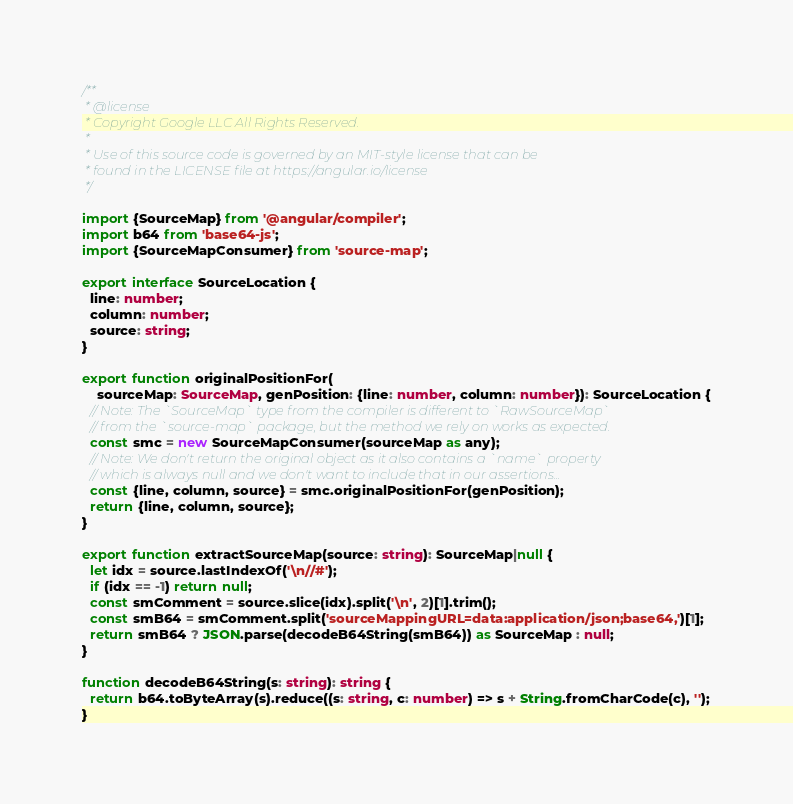Convert code to text. <code><loc_0><loc_0><loc_500><loc_500><_TypeScript_>/**
 * @license
 * Copyright Google LLC All Rights Reserved.
 *
 * Use of this source code is governed by an MIT-style license that can be
 * found in the LICENSE file at https://angular.io/license
 */

import {SourceMap} from '@angular/compiler';
import b64 from 'base64-js';
import {SourceMapConsumer} from 'source-map';

export interface SourceLocation {
  line: number;
  column: number;
  source: string;
}

export function originalPositionFor(
    sourceMap: SourceMap, genPosition: {line: number, column: number}): SourceLocation {
  // Note: The `SourceMap` type from the compiler is different to `RawSourceMap`
  // from the `source-map` package, but the method we rely on works as expected.
  const smc = new SourceMapConsumer(sourceMap as any);
  // Note: We don't return the original object as it also contains a `name` property
  // which is always null and we don't want to include that in our assertions...
  const {line, column, source} = smc.originalPositionFor(genPosition);
  return {line, column, source};
}

export function extractSourceMap(source: string): SourceMap|null {
  let idx = source.lastIndexOf('\n//#');
  if (idx == -1) return null;
  const smComment = source.slice(idx).split('\n', 2)[1].trim();
  const smB64 = smComment.split('sourceMappingURL=data:application/json;base64,')[1];
  return smB64 ? JSON.parse(decodeB64String(smB64)) as SourceMap : null;
}

function decodeB64String(s: string): string {
  return b64.toByteArray(s).reduce((s: string, c: number) => s + String.fromCharCode(c), '');
}
</code> 